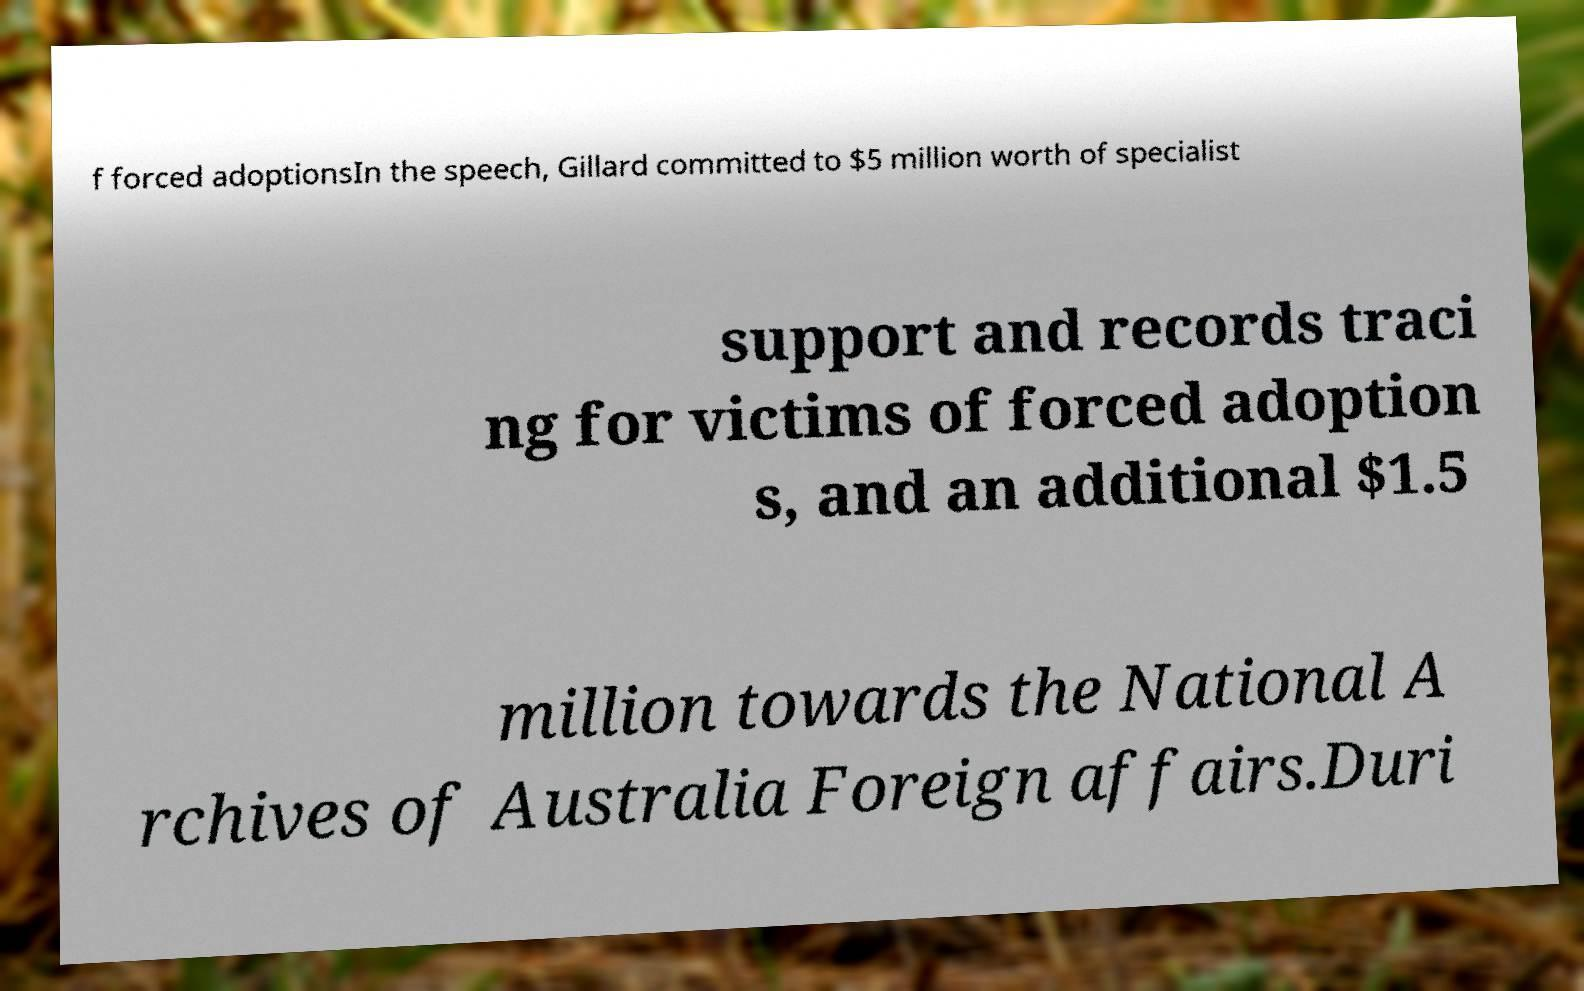Please read and relay the text visible in this image. What does it say? f forced adoptionsIn the speech, Gillard committed to $5 million worth of specialist support and records traci ng for victims of forced adoption s, and an additional $1.5 million towards the National A rchives of Australia Foreign affairs.Duri 